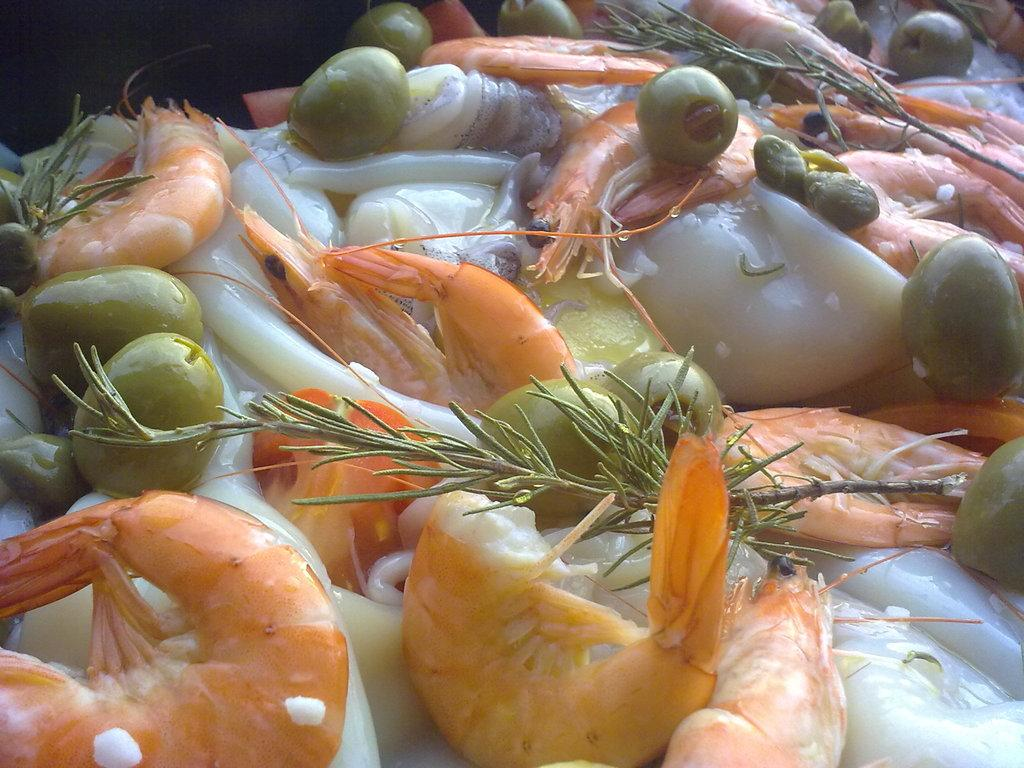What is the main subject of the image? The main subject of the image is prawns, which are located in the center of the image. Are there any other food items visible in the image? Yes, there are other food items visible in the image. What type of theory can be seen being discussed by the chairs in the image? There are no chairs or theories present in the image; it features prawns and other food items. What type of fowl is visible in the image? There is no fowl present in the image; it features prawns and other food items. 